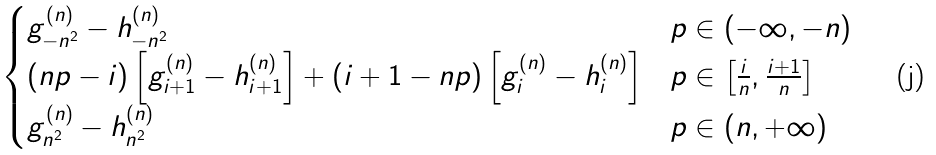Convert formula to latex. <formula><loc_0><loc_0><loc_500><loc_500>\begin{cases} g _ { - n ^ { 2 } } ^ { ( n ) } - h _ { - n ^ { 2 } } ^ { ( n ) } & p \in ( - \infty , - n ) \\ ( n p - i ) \left [ g _ { i + 1 } ^ { ( n ) } - h _ { i + 1 } ^ { ( n ) } \right ] + ( i + 1 - n p ) \left [ g _ { i } ^ { ( n ) } - h _ { i } ^ { ( n ) } \right ] & p \in \left [ \frac { i } { n } , \frac { i + 1 } { n } \right ] \\ g _ { n ^ { 2 } } ^ { ( n ) } - h _ { n ^ { 2 } } ^ { ( n ) } & p \in ( n , + \infty ) \\ \end{cases}</formula> 